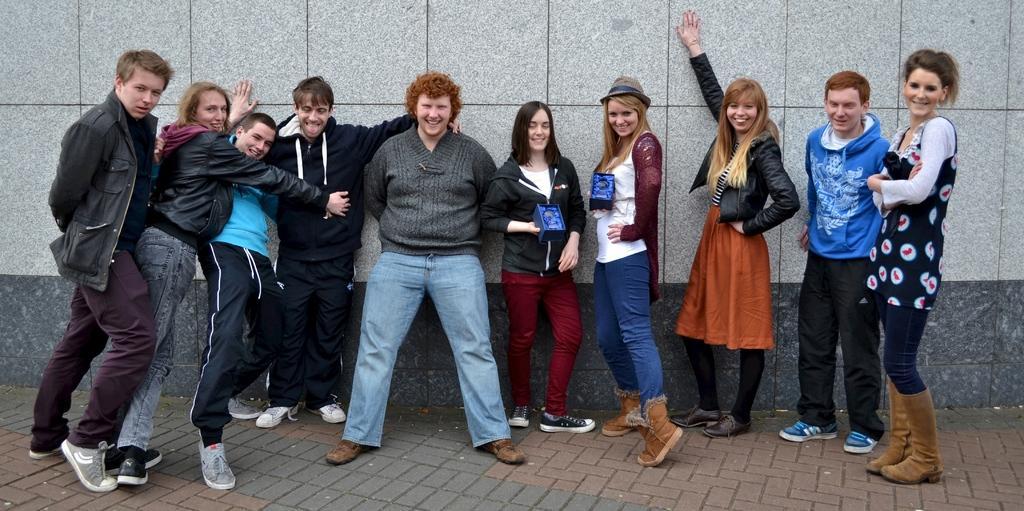Please provide a concise description of this image. In the center of the image there are persons standing. In the background of the image there is a wall. In the bottom of the image there is road. 